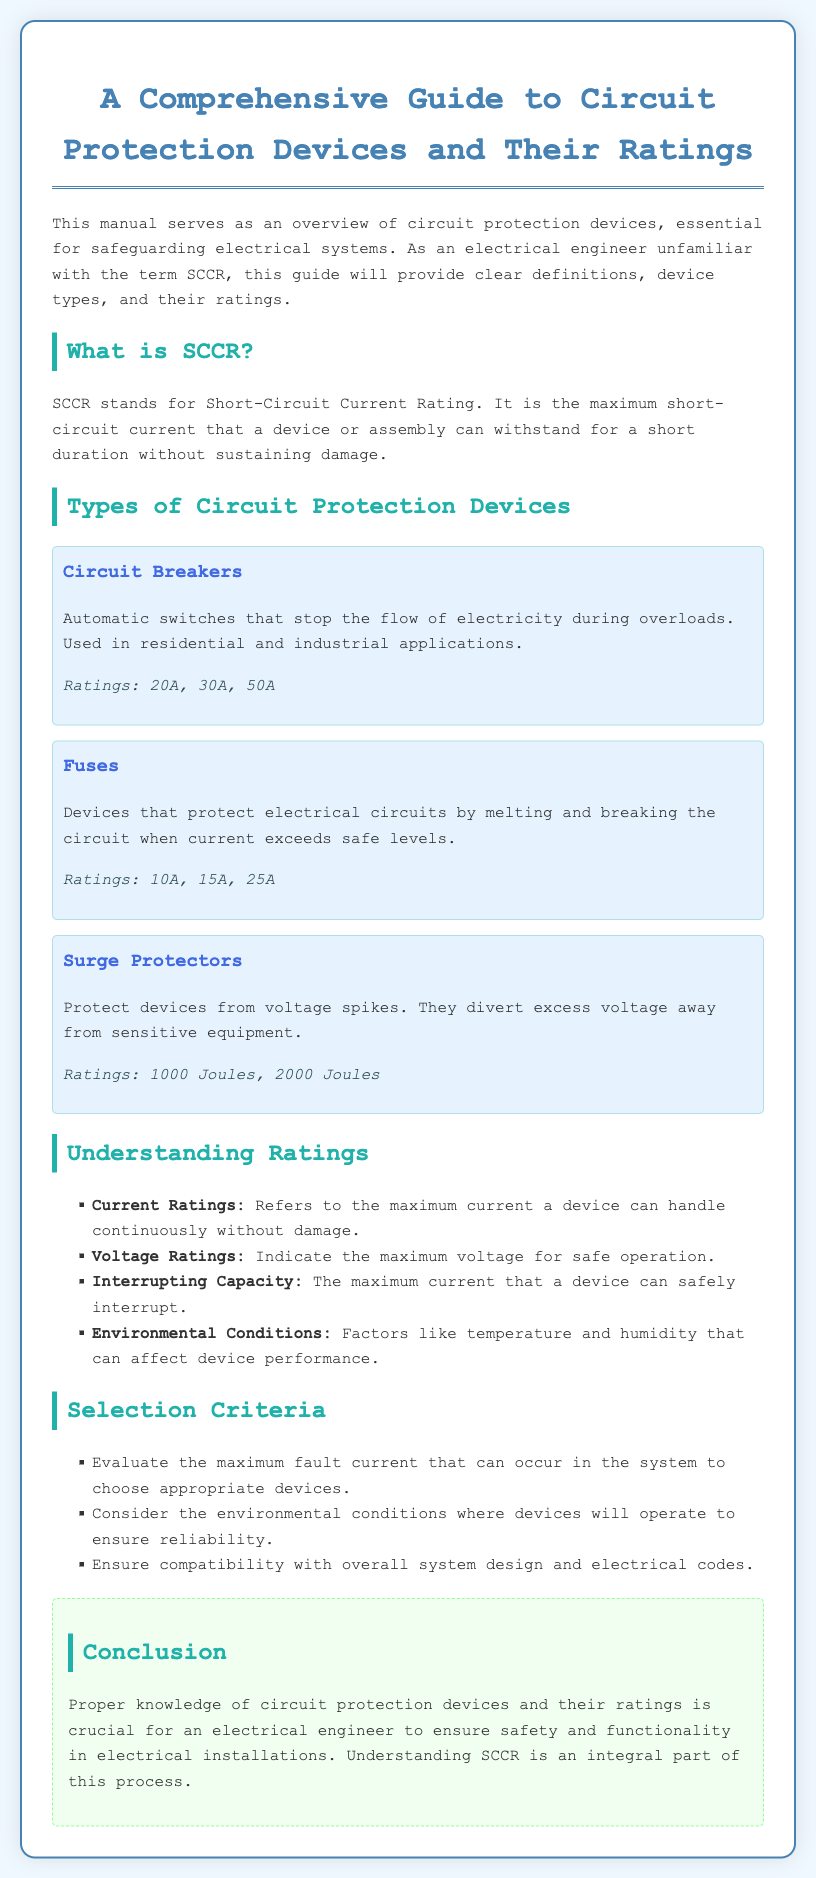What does SCCR stand for? SCCR is defined in the document as the Short-Circuit Current Rating.
Answer: Short-Circuit Current Rating What are the ratings for Circuit Breakers? The document provides the ratings of Circuit Breakers as 20A, 30A, and 50A.
Answer: 20A, 30A, 50A What type of device protects against voltage spikes? The manual states that Surge Protectors are designed to protect against voltage spikes.
Answer: Surge Protectors What is the maximum short-circuit current a device can withstand called? The document refers to this maximum short-circuit current as the SCCR.
Answer: SCCR What should be evaluated when selecting a circuit protection device? The document advises evaluating the maximum fault current for appropriate device selection.
Answer: Maximum fault current What environmental factors can affect device performance? The document mentions temperature and humidity as environmental conditions affecting performance.
Answer: Temperature and humidity What is the minimum current rating for Fuses? According to the document, the ratings for Fuses start at 10A.
Answer: 10A What is the function of a Fuse? The document states that Fuses melt and break the circuit when current exceeds safe levels.
Answer: Melt and break the circuit What is crucial for an electrical engineer according to the conclusion? The conclusion emphasizes that knowledge of circuit protection devices and their ratings is crucial.
Answer: Knowledge of circuit protection devices and their ratings 